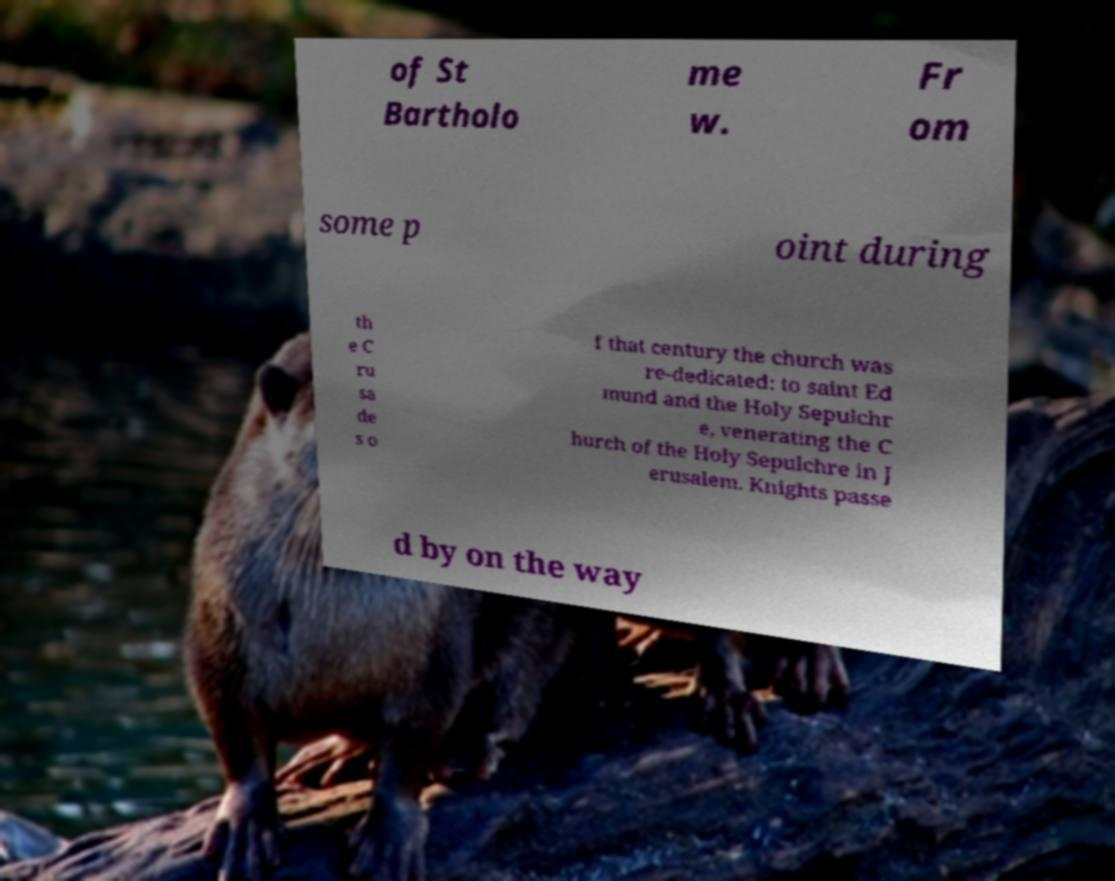Can you read and provide the text displayed in the image?This photo seems to have some interesting text. Can you extract and type it out for me? of St Bartholo me w. Fr om some p oint during th e C ru sa de s o f that century the church was re-dedicated: to saint Ed mund and the Holy Sepulchr e, venerating the C hurch of the Holy Sepulchre in J erusalem. Knights passe d by on the way 